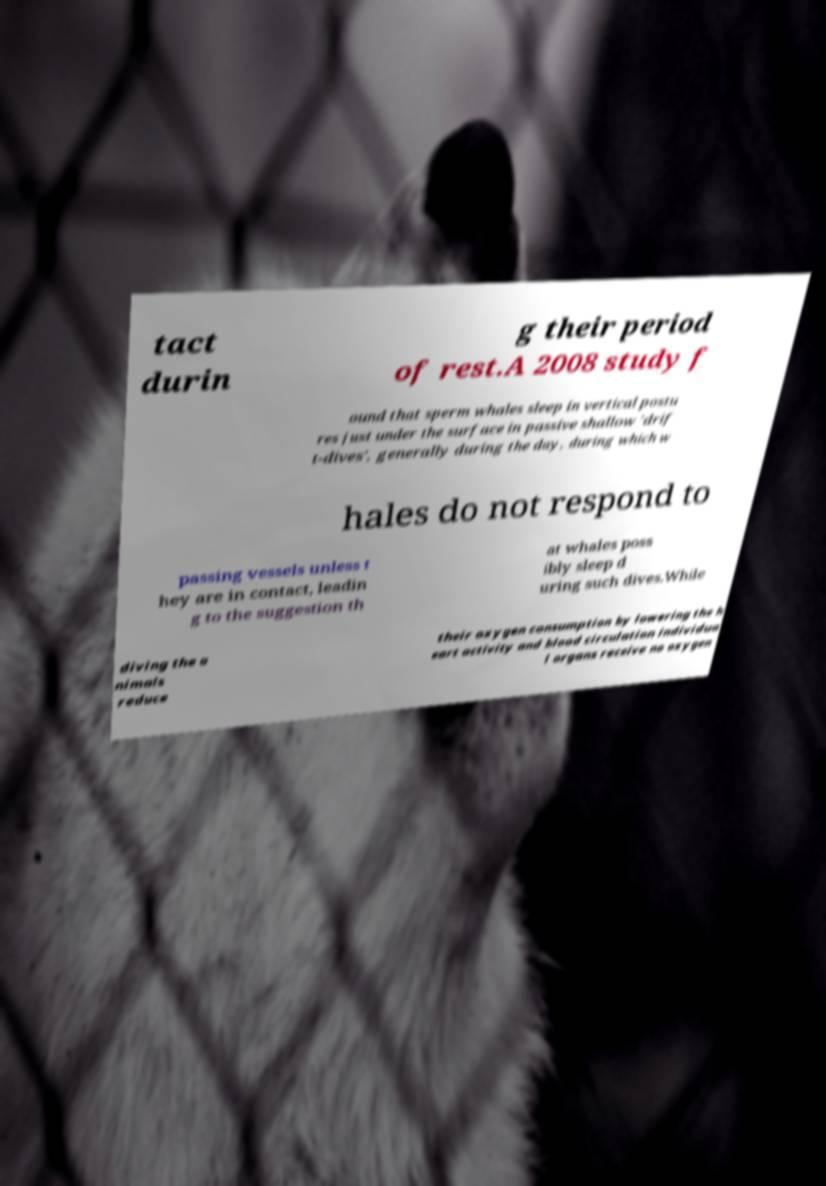Could you assist in decoding the text presented in this image and type it out clearly? tact durin g their period of rest.A 2008 study f ound that sperm whales sleep in vertical postu res just under the surface in passive shallow 'drif t-dives', generally during the day, during which w hales do not respond to passing vessels unless t hey are in contact, leadin g to the suggestion th at whales poss ibly sleep d uring such dives.While diving the a nimals reduce their oxygen consumption by lowering the h eart activity and blood circulation individua l organs receive no oxygen 